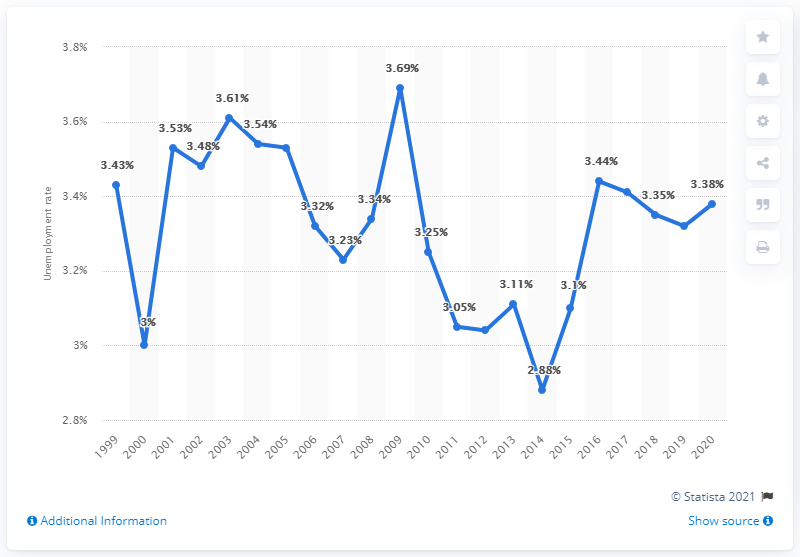Point out several critical features in this image. As of 2020, the unemployment rate in Malaysia was 3.38%. 